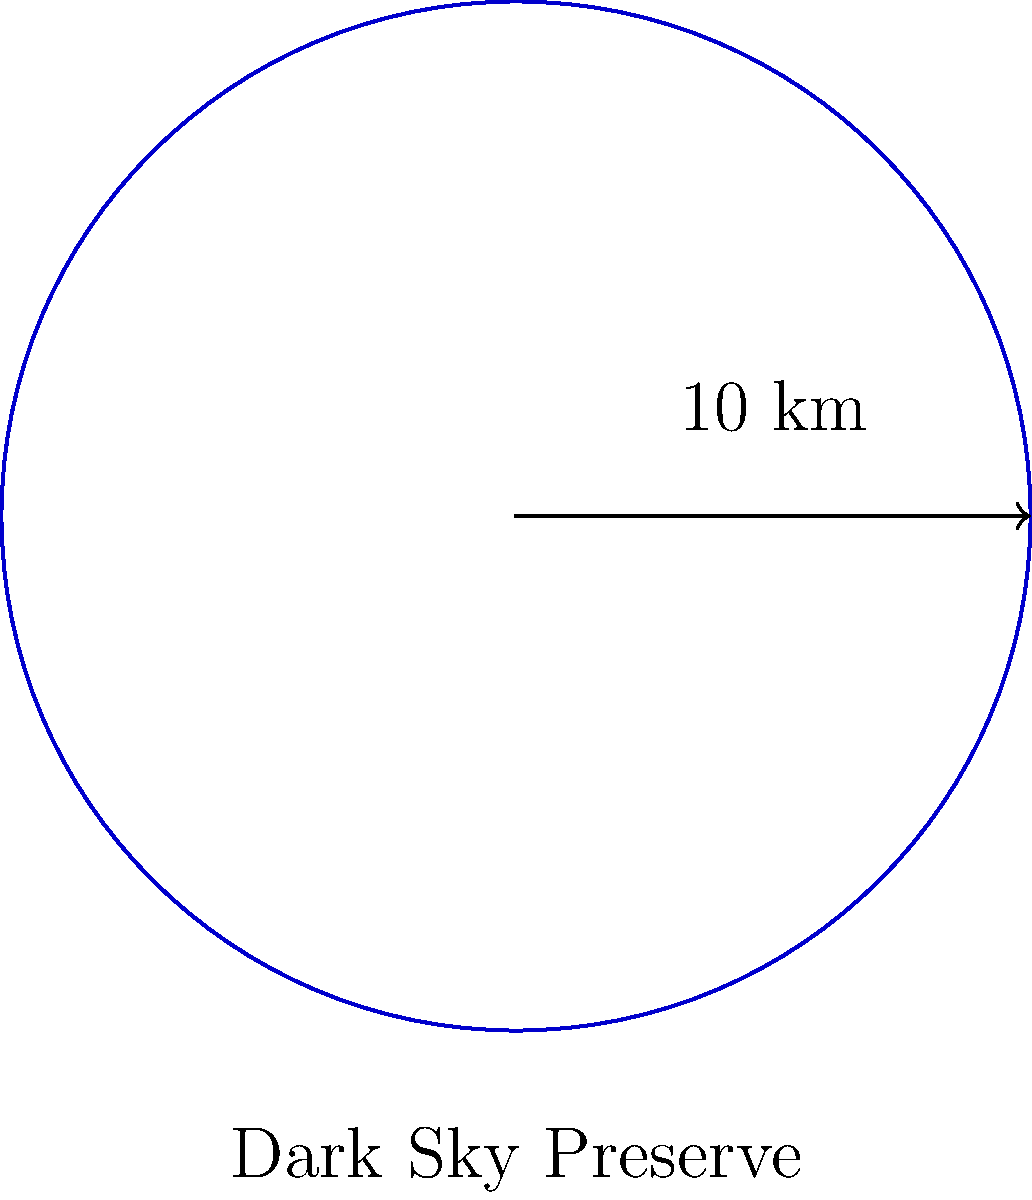A circular dark sky preserve is being established to protect nocturnal wildlife and promote stargazing. If the preserve has a radius of 10 km, what is the total area that will be protected from light pollution? To calculate the area of a circular dark sky preserve, we need to use the formula for the area of a circle:

$$A = \pi r^2$$

Where:
$A$ = area of the circle
$\pi$ = pi (approximately 3.14159)
$r$ = radius of the circle

Given:
Radius ($r$) = 10 km

Step 1: Substitute the given radius into the formula.
$$A = \pi (10 \text{ km})^2$$

Step 2: Calculate the square of the radius.
$$A = \pi (100 \text{ km}^2)$$

Step 3: Multiply by π.
$$A = 314.159 \text{ km}^2$$

Step 4: Round to a reasonable number of significant figures (in this case, three).
$$A \approx 314 \text{ km}^2$$

Therefore, the total area of the dark sky preserve that will be protected from light pollution is approximately 314 square kilometers.
Answer: 314 km² 